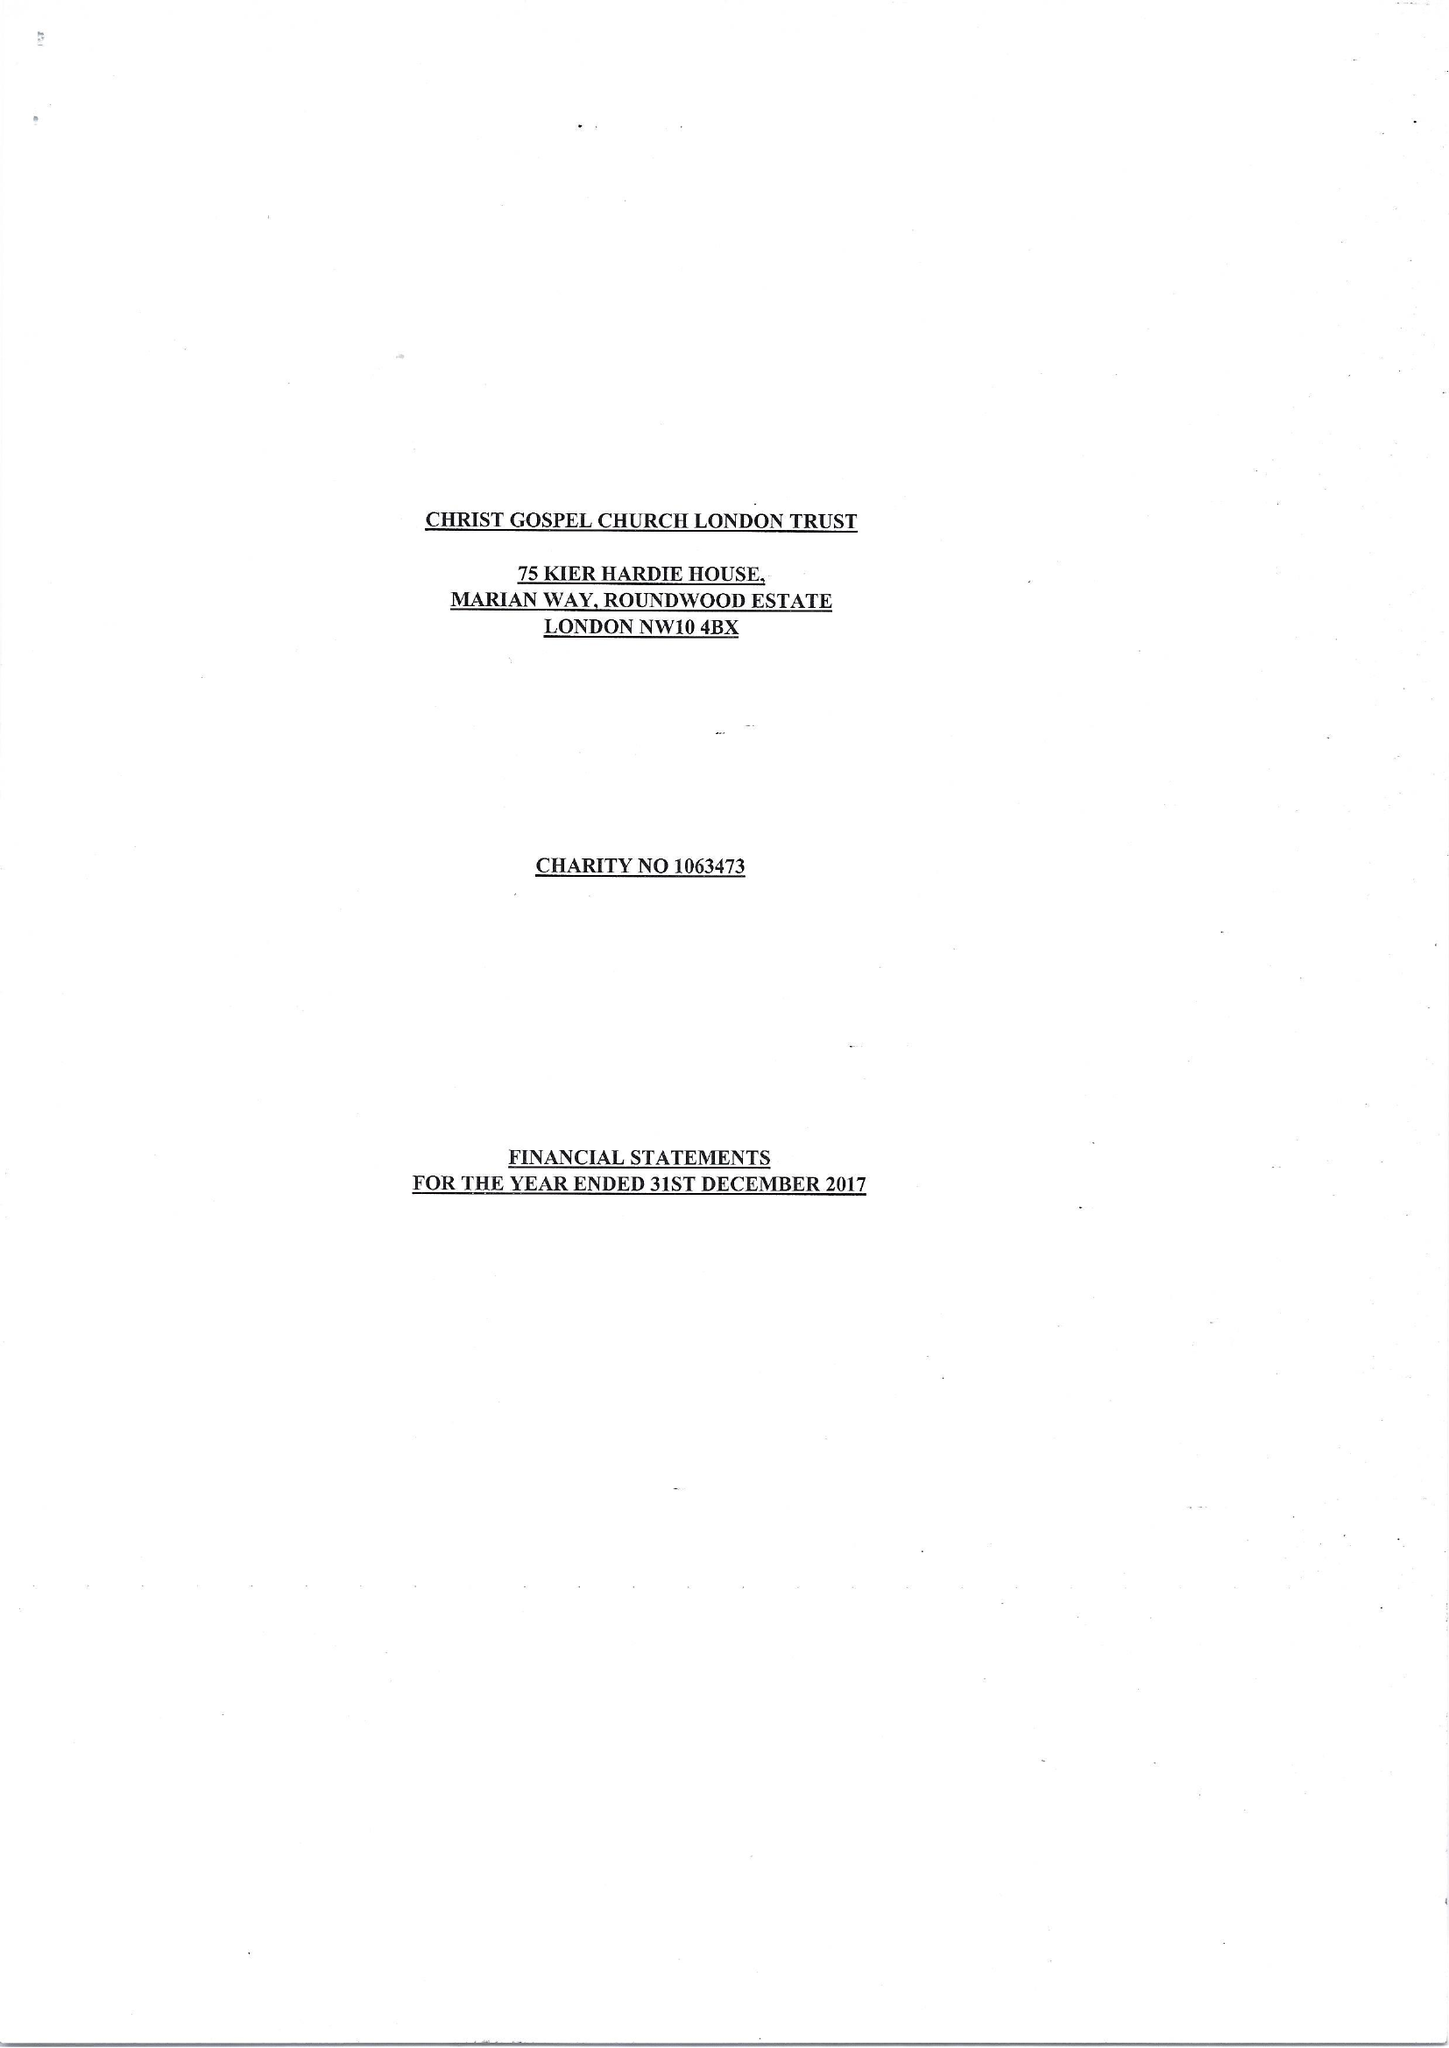What is the value for the address__postcode?
Answer the question using a single word or phrase. NW10 4BX 